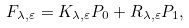<formula> <loc_0><loc_0><loc_500><loc_500>F _ { \lambda , \varepsilon } = K _ { \lambda , \varepsilon } P _ { 0 } + R _ { \lambda , \varepsilon } P _ { 1 } ,</formula> 